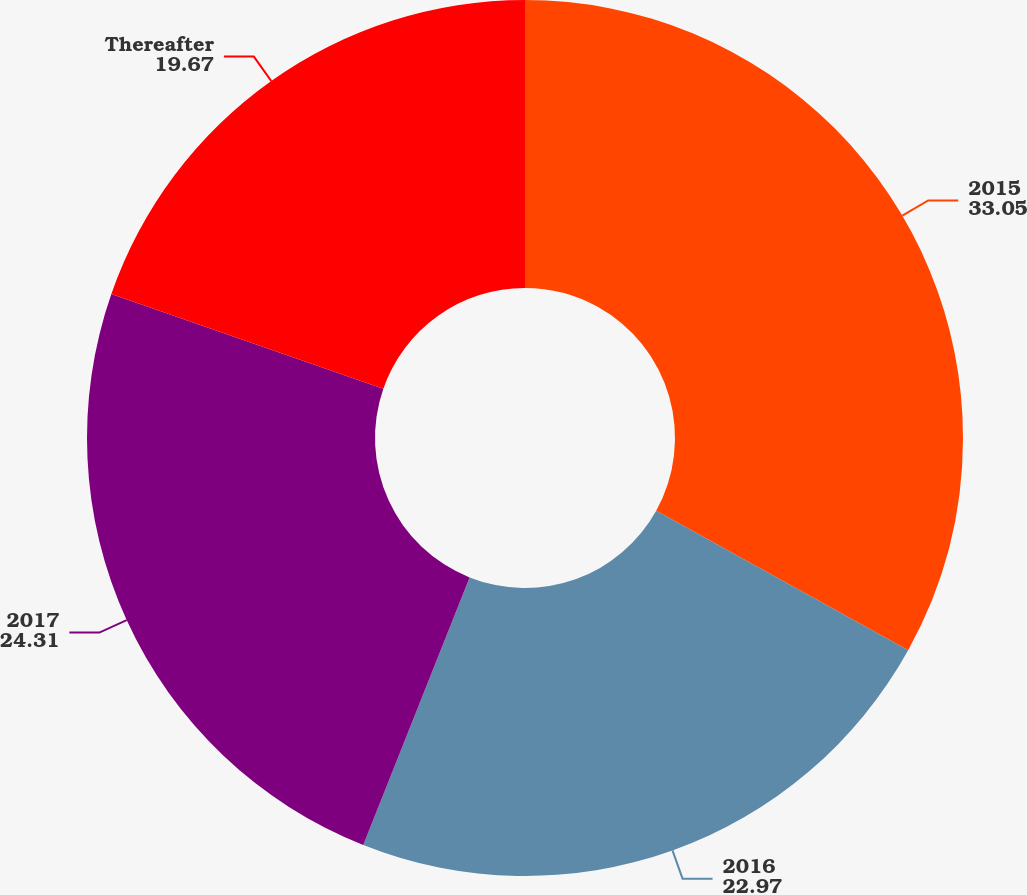Convert chart to OTSL. <chart><loc_0><loc_0><loc_500><loc_500><pie_chart><fcel>2015<fcel>2016<fcel>2017<fcel>Thereafter<nl><fcel>33.05%<fcel>22.97%<fcel>24.31%<fcel>19.67%<nl></chart> 